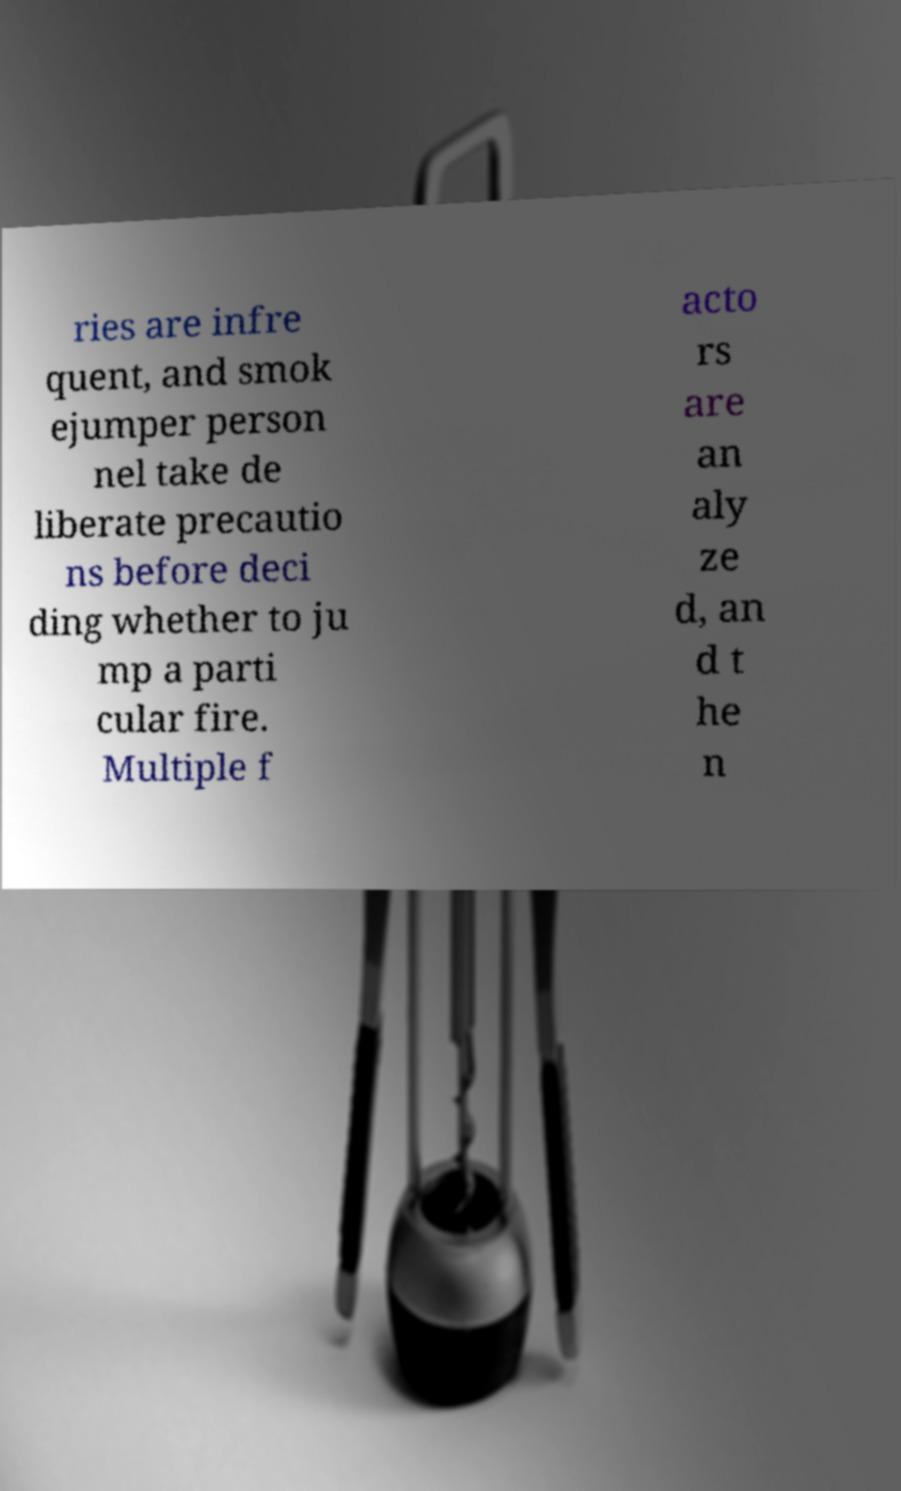I need the written content from this picture converted into text. Can you do that? ries are infre quent, and smok ejumper person nel take de liberate precautio ns before deci ding whether to ju mp a parti cular fire. Multiple f acto rs are an aly ze d, an d t he n 